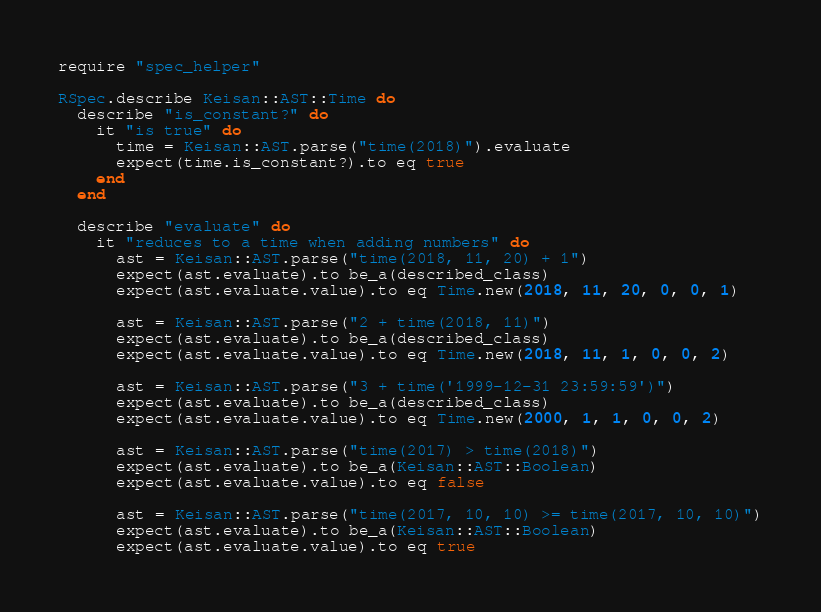Convert code to text. <code><loc_0><loc_0><loc_500><loc_500><_Ruby_>require "spec_helper"

RSpec.describe Keisan::AST::Time do
  describe "is_constant?" do
    it "is true" do
      time = Keisan::AST.parse("time(2018)").evaluate
      expect(time.is_constant?).to eq true
    end
  end

  describe "evaluate" do
    it "reduces to a time when adding numbers" do
      ast = Keisan::AST.parse("time(2018, 11, 20) + 1")
      expect(ast.evaluate).to be_a(described_class)
      expect(ast.evaluate.value).to eq Time.new(2018, 11, 20, 0, 0, 1)

      ast = Keisan::AST.parse("2 + time(2018, 11)")
      expect(ast.evaluate).to be_a(described_class)
      expect(ast.evaluate.value).to eq Time.new(2018, 11, 1, 0, 0, 2)

      ast = Keisan::AST.parse("3 + time('1999-12-31 23:59:59')")
      expect(ast.evaluate).to be_a(described_class)
      expect(ast.evaluate.value).to eq Time.new(2000, 1, 1, 0, 0, 2)

      ast = Keisan::AST.parse("time(2017) > time(2018)")
      expect(ast.evaluate).to be_a(Keisan::AST::Boolean)
      expect(ast.evaluate.value).to eq false

      ast = Keisan::AST.parse("time(2017, 10, 10) >= time(2017, 10, 10)")
      expect(ast.evaluate).to be_a(Keisan::AST::Boolean)
      expect(ast.evaluate.value).to eq true
</code> 